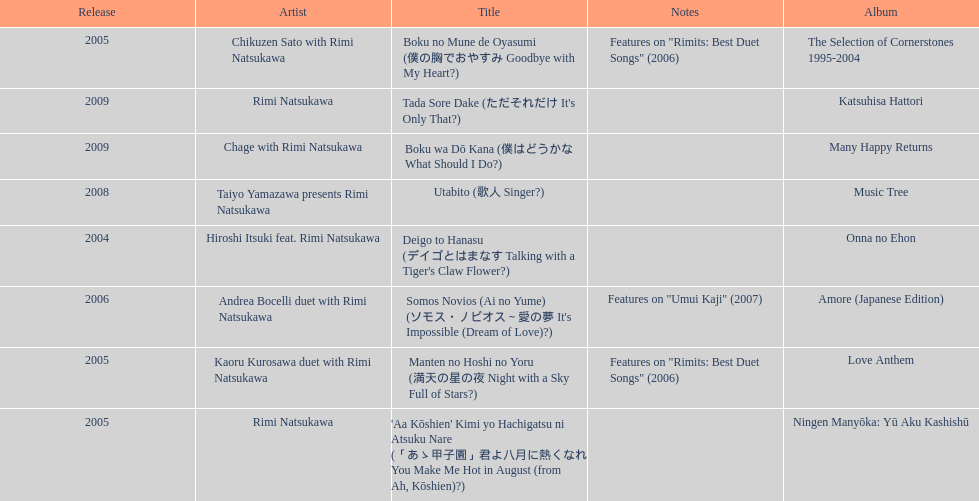What is the quantity of albums published in collaboration with the artist rimi natsukawa? 8. 